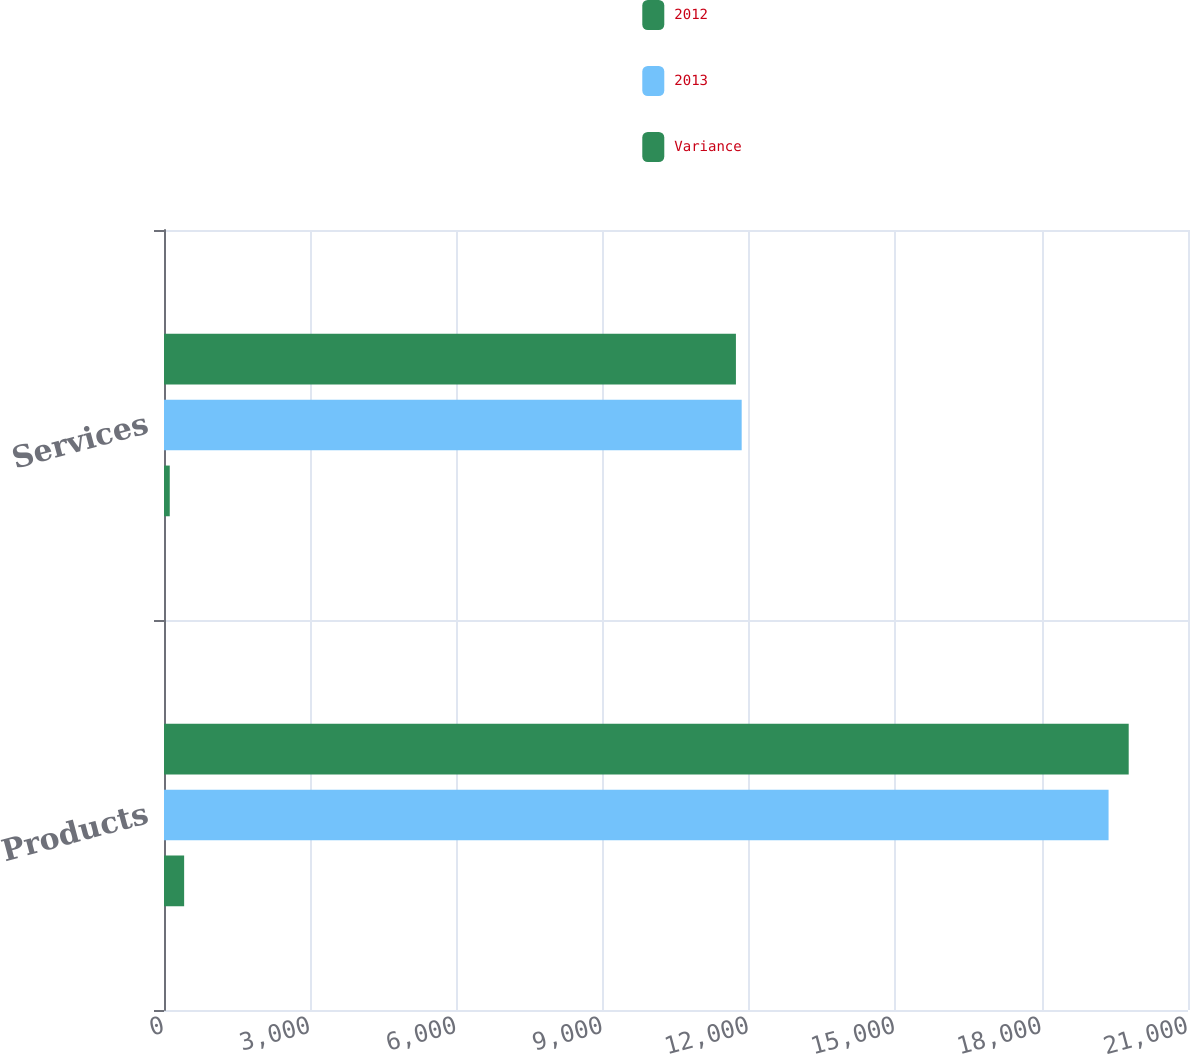<chart> <loc_0><loc_0><loc_500><loc_500><stacked_bar_chart><ecel><fcel>Products<fcel>Services<nl><fcel>2012<fcel>19784<fcel>11729<nl><fcel>2013<fcel>19371<fcel>11847<nl><fcel>Variance<fcel>413<fcel>118<nl></chart> 